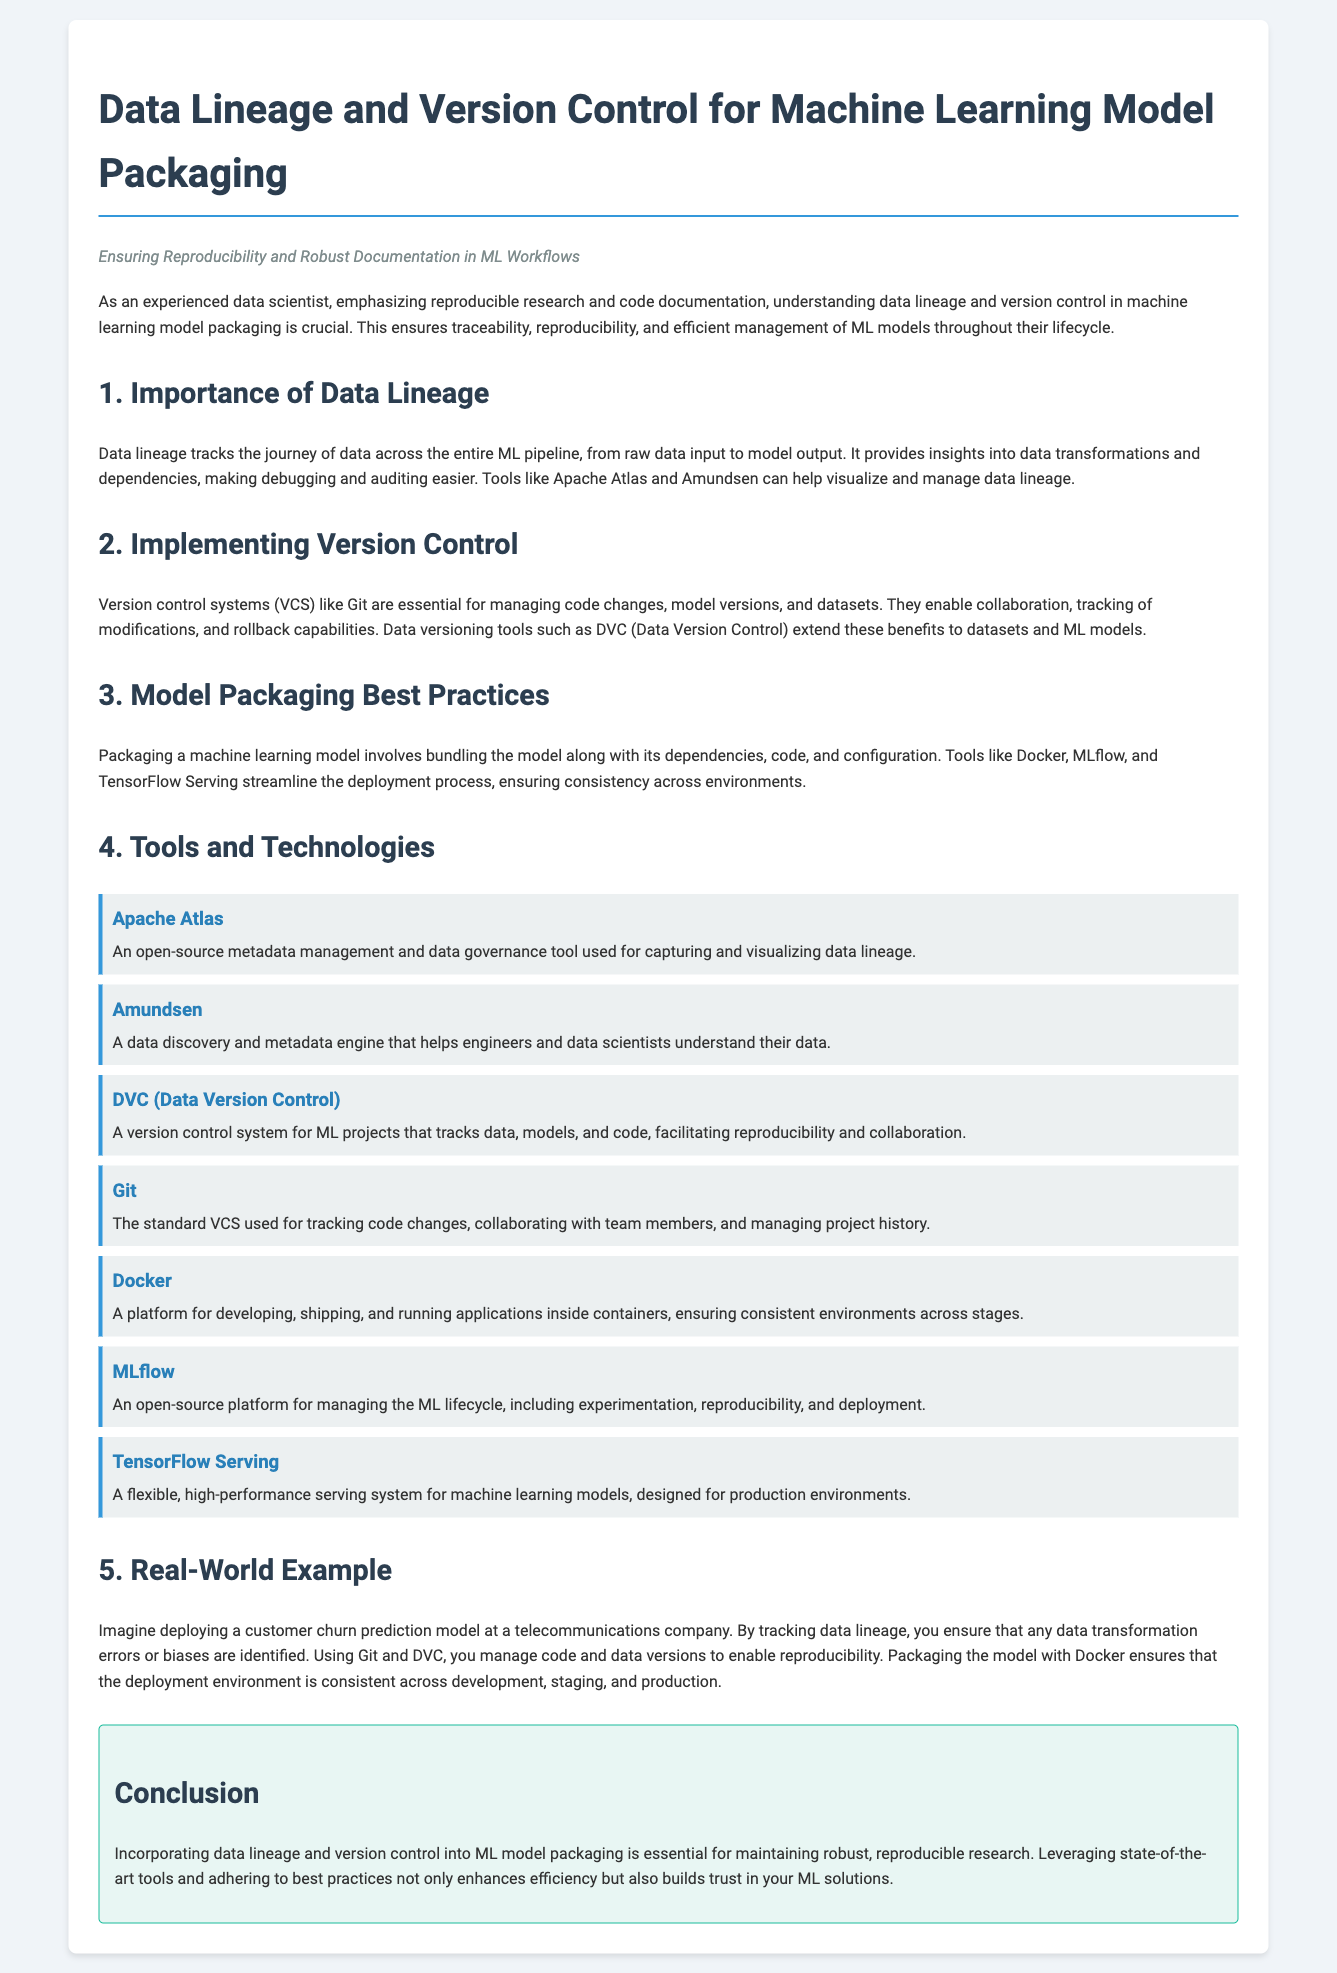what is the title of the document? The title is found in the header section of the document.
Answer: Data Lineage and Version Control for Machine Learning Model Packaging what is the subtitle of the document? The subtitle provides additional context and is also found in the header section.
Answer: Ensuring Reproducibility and Robust Documentation in ML Workflows which tool is used for visualizing data lineage? The document mentions specific tools for managing data lineage under the "Tools and Technologies" section.
Answer: Apache Atlas what is the primary version control system mentioned? The document discusses version control systems and highlights a specific one used commonly in coding.
Answer: Git how many sections are there in the document? The document is divided into multiple sections, each covering a different aspect of the topic.
Answer: Five which tool is specifically designed for managing the ML lifecycle? This tool is mentioned as part of the "Tools and Technologies" section related to ML management.
Answer: MLflow what is a benefit of using DVC? The document explains the advantages of using this tool within its context.
Answer: Reproducibility what is the real-world example provided in the document about? The example illustrates the practical application of the concepts discussed.
Answer: Customer churn prediction model what is one of the benefits of tracking data lineage? This benefit is mentioned in relation to debugging and auditing in the document.
Answer: Debugging what is the color of the background in the document's container? The document describes the styling details, including the background color.
Answer: White 